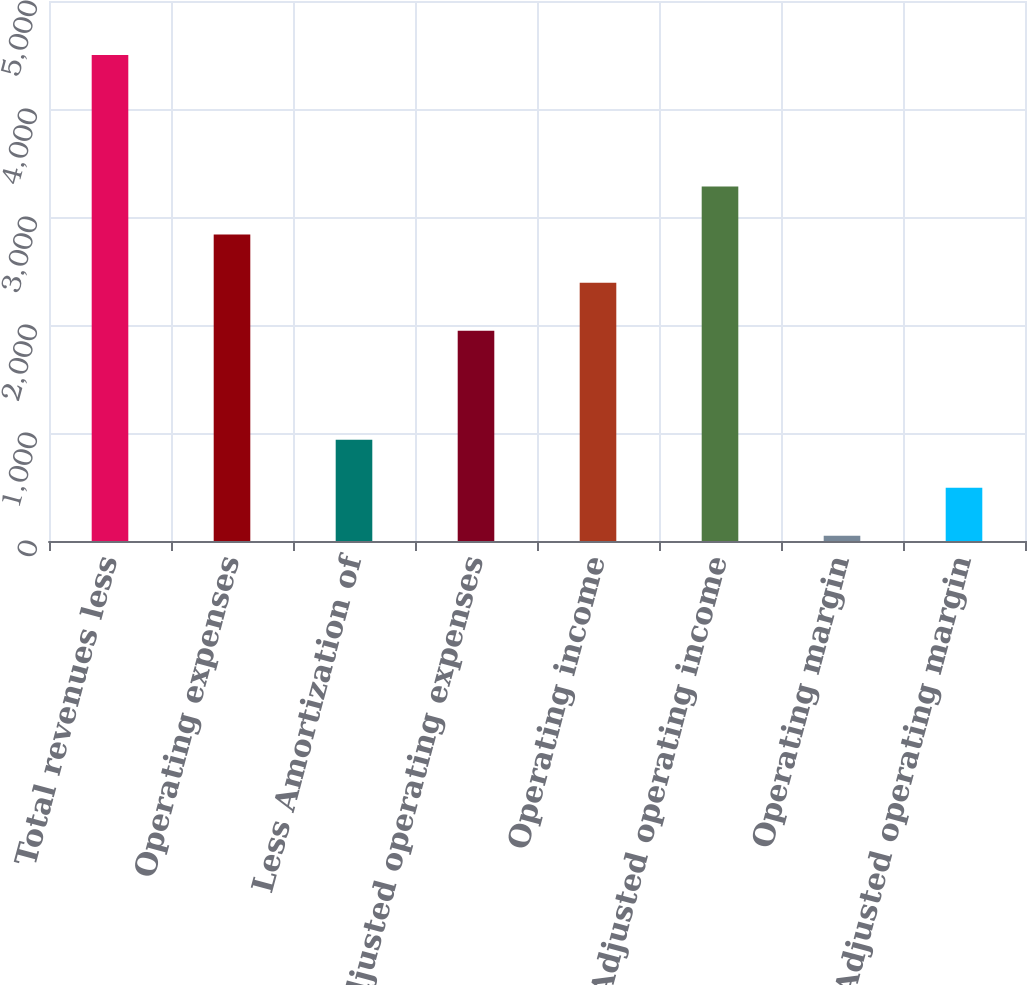<chart> <loc_0><loc_0><loc_500><loc_500><bar_chart><fcel>Total revenues less<fcel>Operating expenses<fcel>Less Amortization of<fcel>Adjusted operating expenses<fcel>Operating income<fcel>Adjusted operating income<fcel>Operating margin<fcel>Adjusted operating margin<nl><fcel>4499<fcel>2837.2<fcel>938.2<fcel>1947<fcel>2392.1<fcel>3282.3<fcel>48<fcel>493.1<nl></chart> 